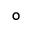Convert formula to latex. <formula><loc_0><loc_0><loc_500><loc_500>^ { \circ }</formula> 